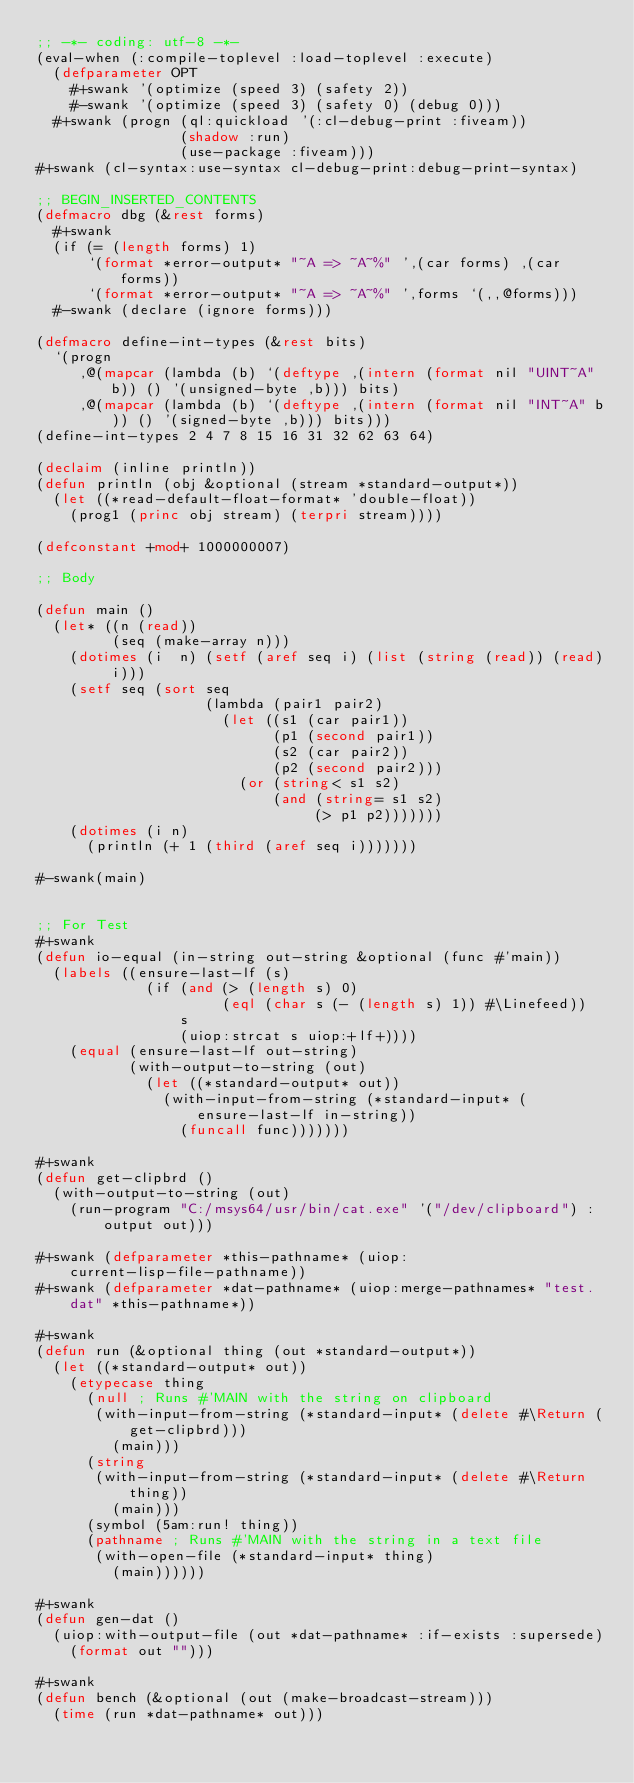<code> <loc_0><loc_0><loc_500><loc_500><_Lisp_>;; -*- coding: utf-8 -*-
(eval-when (:compile-toplevel :load-toplevel :execute)
  (defparameter OPT
    #+swank '(optimize (speed 3) (safety 2))
    #-swank '(optimize (speed 3) (safety 0) (debug 0)))
  #+swank (progn (ql:quickload '(:cl-debug-print :fiveam))
                 (shadow :run)
                 (use-package :fiveam)))
#+swank (cl-syntax:use-syntax cl-debug-print:debug-print-syntax)

;; BEGIN_INSERTED_CONTENTS
(defmacro dbg (&rest forms)
  #+swank
  (if (= (length forms) 1)
      `(format *error-output* "~A => ~A~%" ',(car forms) ,(car forms))
      `(format *error-output* "~A => ~A~%" ',forms `(,,@forms)))
  #-swank (declare (ignore forms)))

(defmacro define-int-types (&rest bits)
  `(progn
     ,@(mapcar (lambda (b) `(deftype ,(intern (format nil "UINT~A" b)) () '(unsigned-byte ,b))) bits)
     ,@(mapcar (lambda (b) `(deftype ,(intern (format nil "INT~A" b)) () '(signed-byte ,b))) bits)))
(define-int-types 2 4 7 8 15 16 31 32 62 63 64)

(declaim (inline println))
(defun println (obj &optional (stream *standard-output*))
  (let ((*read-default-float-format* 'double-float))
    (prog1 (princ obj stream) (terpri stream))))

(defconstant +mod+ 1000000007)

;; Body

(defun main ()
  (let* ((n (read))
         (seq (make-array n)))
    (dotimes (i  n) (setf (aref seq i) (list (string (read)) (read) i)))
    (setf seq (sort seq
                    (lambda (pair1 pair2)
                      (let ((s1 (car pair1))
                            (p1 (second pair1))
                            (s2 (car pair2))
                            (p2 (second pair2)))
                        (or (string< s1 s2)
                            (and (string= s1 s2)
                                 (> p1 p2)))))))
    (dotimes (i n)
      (println (+ 1 (third (aref seq i)))))))

#-swank(main)


;; For Test
#+swank
(defun io-equal (in-string out-string &optional (func #'main))
  (labels ((ensure-last-lf (s)
             (if (and (> (length s) 0)
                      (eql (char s (- (length s) 1)) #\Linefeed))
                 s
                 (uiop:strcat s uiop:+lf+))))
    (equal (ensure-last-lf out-string)
           (with-output-to-string (out)
             (let ((*standard-output* out))
               (with-input-from-string (*standard-input* (ensure-last-lf in-string))
                 (funcall func)))))))

#+swank
(defun get-clipbrd ()
  (with-output-to-string (out)
    (run-program "C:/msys64/usr/bin/cat.exe" '("/dev/clipboard") :output out)))

#+swank (defparameter *this-pathname* (uiop:current-lisp-file-pathname))
#+swank (defparameter *dat-pathname* (uiop:merge-pathnames* "test.dat" *this-pathname*))

#+swank
(defun run (&optional thing (out *standard-output*))
  (let ((*standard-output* out))
    (etypecase thing
      (null ; Runs #'MAIN with the string on clipboard
       (with-input-from-string (*standard-input* (delete #\Return (get-clipbrd)))
         (main)))
      (string
       (with-input-from-string (*standard-input* (delete #\Return thing))
         (main)))
      (symbol (5am:run! thing))
      (pathname ; Runs #'MAIN with the string in a text file
       (with-open-file (*standard-input* thing)
         (main))))))

#+swank
(defun gen-dat ()
  (uiop:with-output-file (out *dat-pathname* :if-exists :supersede)
    (format out "")))

#+swank
(defun bench (&optional (out (make-broadcast-stream)))
  (time (run *dat-pathname* out)))
</code> 